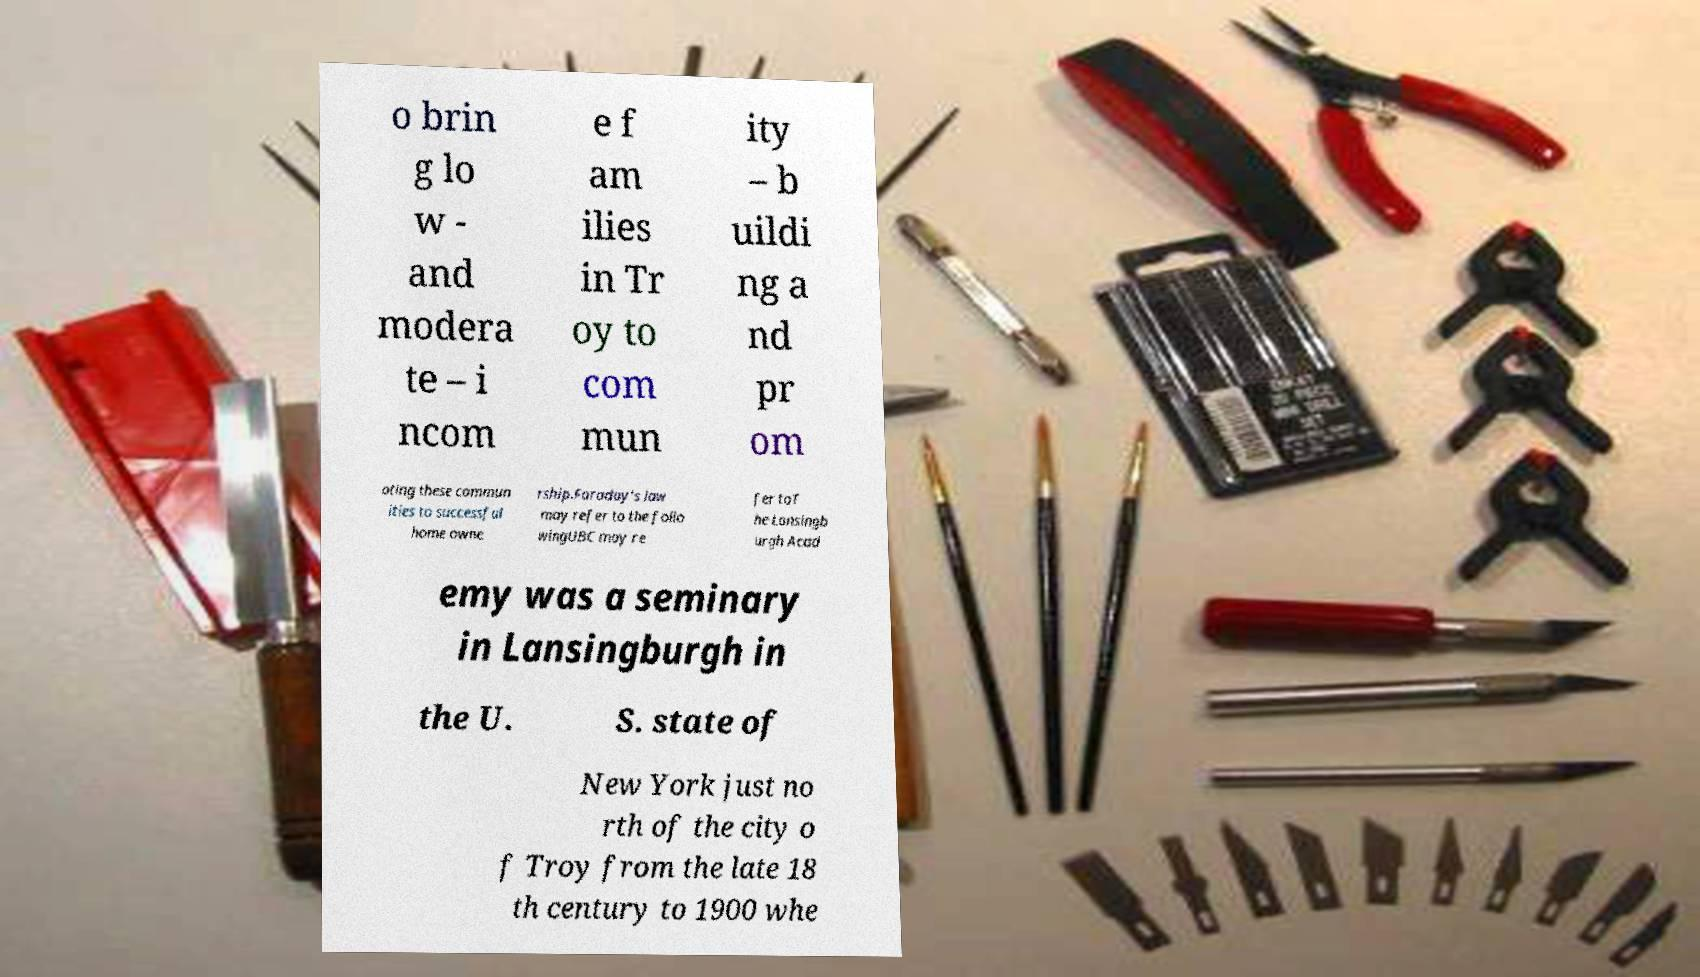Please read and relay the text visible in this image. What does it say? o brin g lo w - and modera te – i ncom e f am ilies in Tr oy to com mun ity – b uildi ng a nd pr om oting these commun ities to successful home owne rship.Faraday's law may refer to the follo wingUBC may re fer toT he Lansingb urgh Acad emy was a seminary in Lansingburgh in the U. S. state of New York just no rth of the city o f Troy from the late 18 th century to 1900 whe 